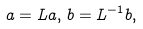Convert formula to latex. <formula><loc_0><loc_0><loc_500><loc_500>a = L a , \, b = L ^ { - 1 } b ,</formula> 